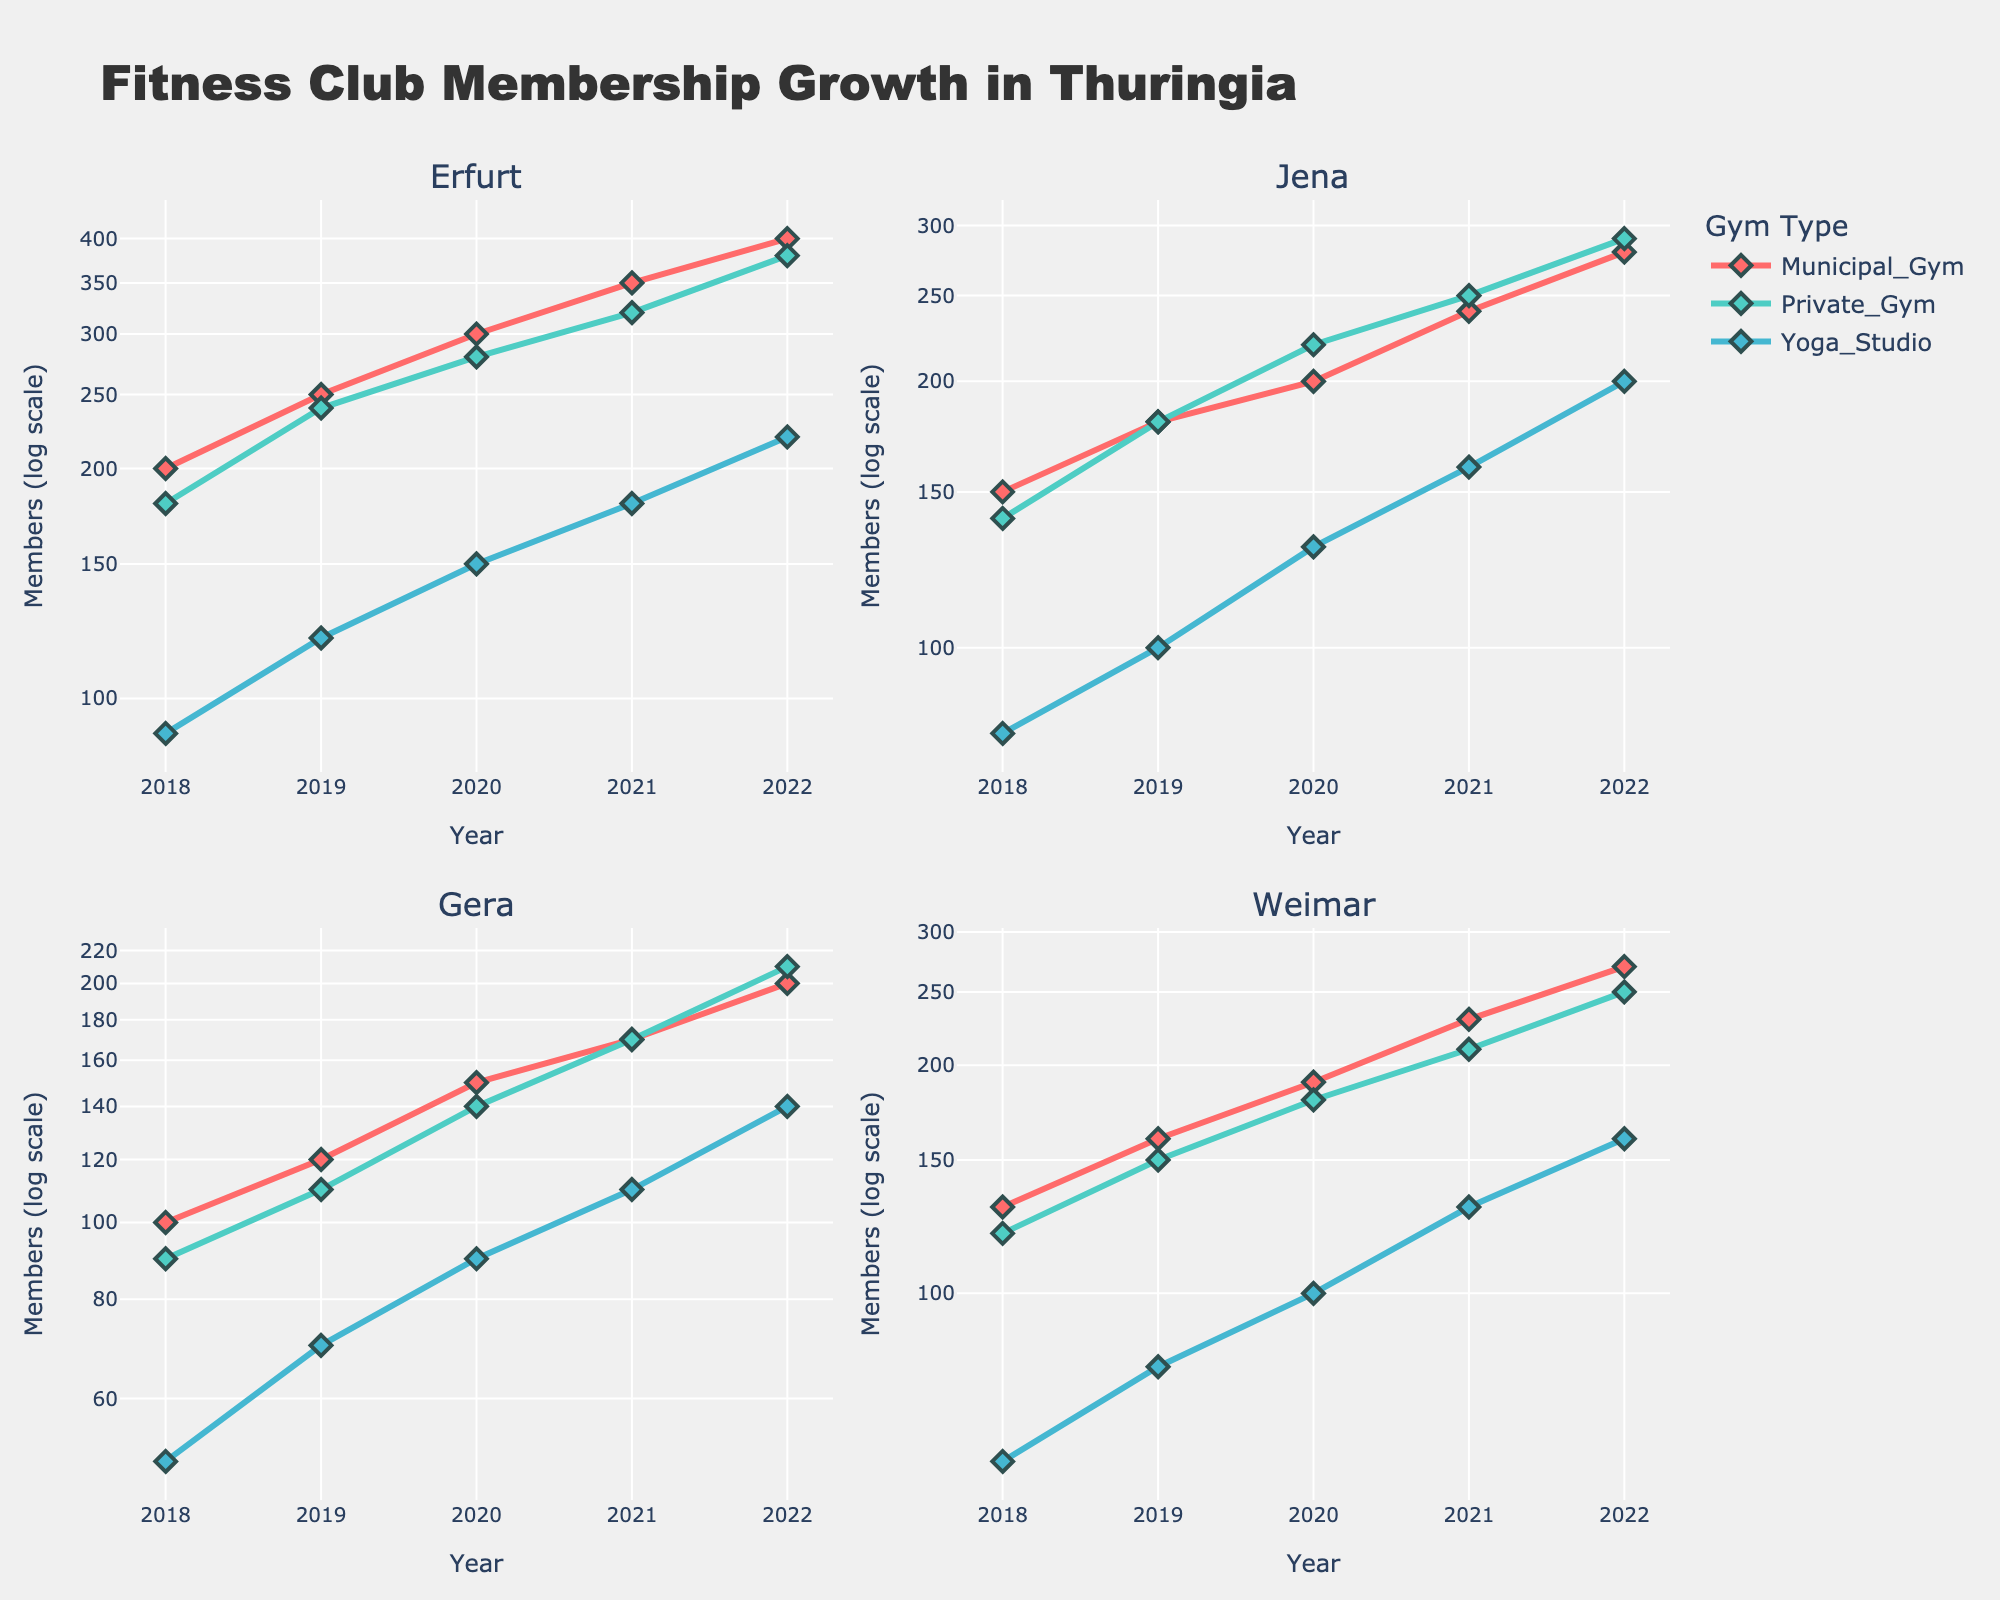What is the title of the figure? The title of the figure is written at the top center of the plot and provides an overview of the figure's content.
Answer: Fitness Club Membership Growth in Thuringia How many cities are compared in the figure? The figure consists of four subplots with titles indicating each city. This means there are four cities compared in total.
Answer: 4 Which city had the highest membership in Private Gyms in 2022? By visually inspecting the subplot for each city and focusing on Private Gym data points for the year 2022, we can see that Erfurt has the highest membership count.
Answer: Erfurt What is the color used for Municipal Gyms in the plots? Each gym type is represented by a different color in the plots. Municipal Gyms are represented by the color that matches their lines and markers.
Answer: Red Which city had the smallest increase in Yoga Studio membership from 2018 to 2022? Determine the increase in Yoga Studio membership for each city between 2018 and 2022, and compare the differences. Gera had the smallest increase (90 to 140, which is an increase of 50).
Answer: Gera Between which years did Erfurt see the largest increase in Municipal Gym membership? By looking at the Municipal Gym data points for Erfurt in consecutive years, we can identify that the largest increase was between 2018 and 2019 (200 to 250, which is an increase of 50 members).
Answer: 2018 to 2019 On the log scale, which city shows the steepest growth in Private Gym membership from 2018 to 2022? To determine the steepest growth, we examine the slope of the Private Gym lines on the log scale for each city. Erfurt has the steepest growth as indicated by the sharpest upward trajectory of the line.
Answer: Erfurt What is the trend observed in Yoga Studio memberships for Weimar from 2018 to 2022? By observing the plot for Weimar and focusing on the data line corresponding to Yoga Studio from 2018 to 2022, the trend shows a steady increase in membership over the years.
Answer: Steady increase Compare the total membership of Municipal Gyms and Private Gyms for Gera in 2020. Which has more members? Sum up the number of members in Gera for both gym types in 2020. Municipal Gym: 150, Private Gym: 140. Therefore, Municipal Gym has more members.
Answer: Municipal Gym In which year did Jena have the same membership for Municipal Gyms and Private Gyms? Look at the Jena subplot and find the year where the data points for Municipal Gyms and Private Gyms coincide. This occurs in 2019 when both memberships were 180.
Answer: 2019 